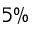Convert formula to latex. <formula><loc_0><loc_0><loc_500><loc_500>5 \%</formula> 